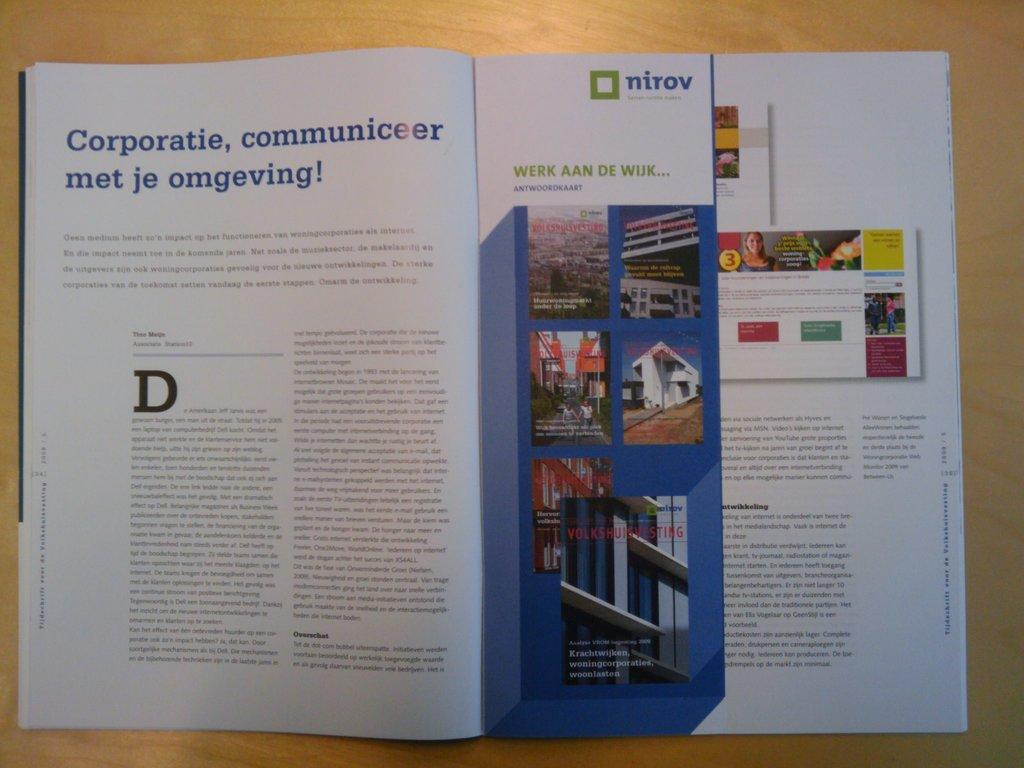Provide a one-sentence caption for the provided image. A magazine is opened to a page that has "nirov" with a green box. 